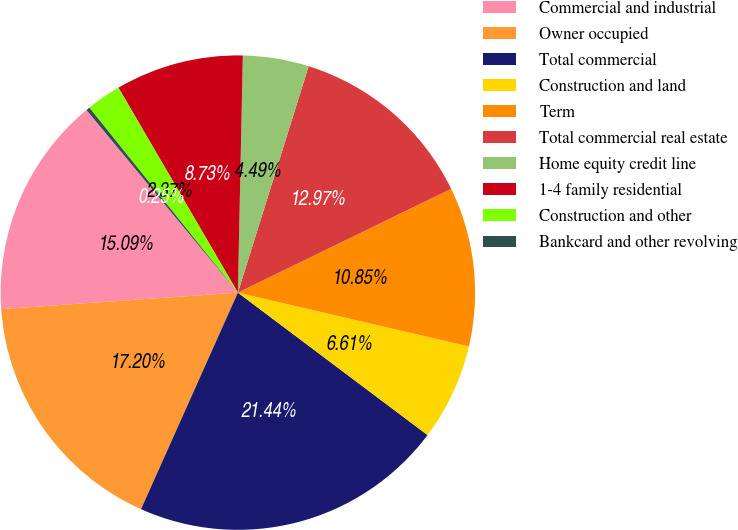<chart> <loc_0><loc_0><loc_500><loc_500><pie_chart><fcel>Commercial and industrial<fcel>Owner occupied<fcel>Total commercial<fcel>Construction and land<fcel>Term<fcel>Total commercial real estate<fcel>Home equity credit line<fcel>1-4 family residential<fcel>Construction and other<fcel>Bankcard and other revolving<nl><fcel>15.09%<fcel>17.2%<fcel>21.44%<fcel>6.61%<fcel>10.85%<fcel>12.97%<fcel>4.49%<fcel>8.73%<fcel>2.37%<fcel>0.25%<nl></chart> 